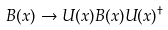<formula> <loc_0><loc_0><loc_500><loc_500>B ( x ) \rightarrow U ( x ) B ( x ) U ( x ) ^ { \dagger }</formula> 